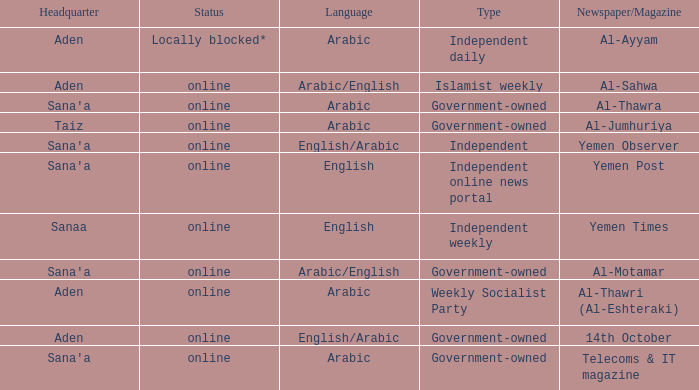What is the classification when newspaper/magazine is about telecoms & it magazine? Government-owned. Can you give me this table as a dict? {'header': ['Headquarter', 'Status', 'Language', 'Type', 'Newspaper/Magazine'], 'rows': [['Aden', 'Locally blocked*', 'Arabic', 'Independent daily', 'Al-Ayyam'], ['Aden', 'online', 'Arabic/English', 'Islamist weekly', 'Al-Sahwa'], ["Sana'a", 'online', 'Arabic', 'Government-owned', 'Al-Thawra'], ['Taiz', 'online', 'Arabic', 'Government-owned', 'Al-Jumhuriya'], ["Sana'a", 'online', 'English/Arabic', 'Independent', 'Yemen Observer'], ["Sana'a", 'online', 'English', 'Independent online news portal', 'Yemen Post'], ['Sanaa', 'online', 'English', 'Independent weekly', 'Yemen Times'], ["Sana'a", 'online', 'Arabic/English', 'Government-owned', 'Al-Motamar'], ['Aden', 'online', 'Arabic', 'Weekly Socialist Party', 'Al-Thawri (Al-Eshteraki)'], ['Aden', 'online', 'English/Arabic', 'Government-owned', '14th October'], ["Sana'a", 'online', 'Arabic', 'Government-owned', 'Telecoms & IT magazine']]} 